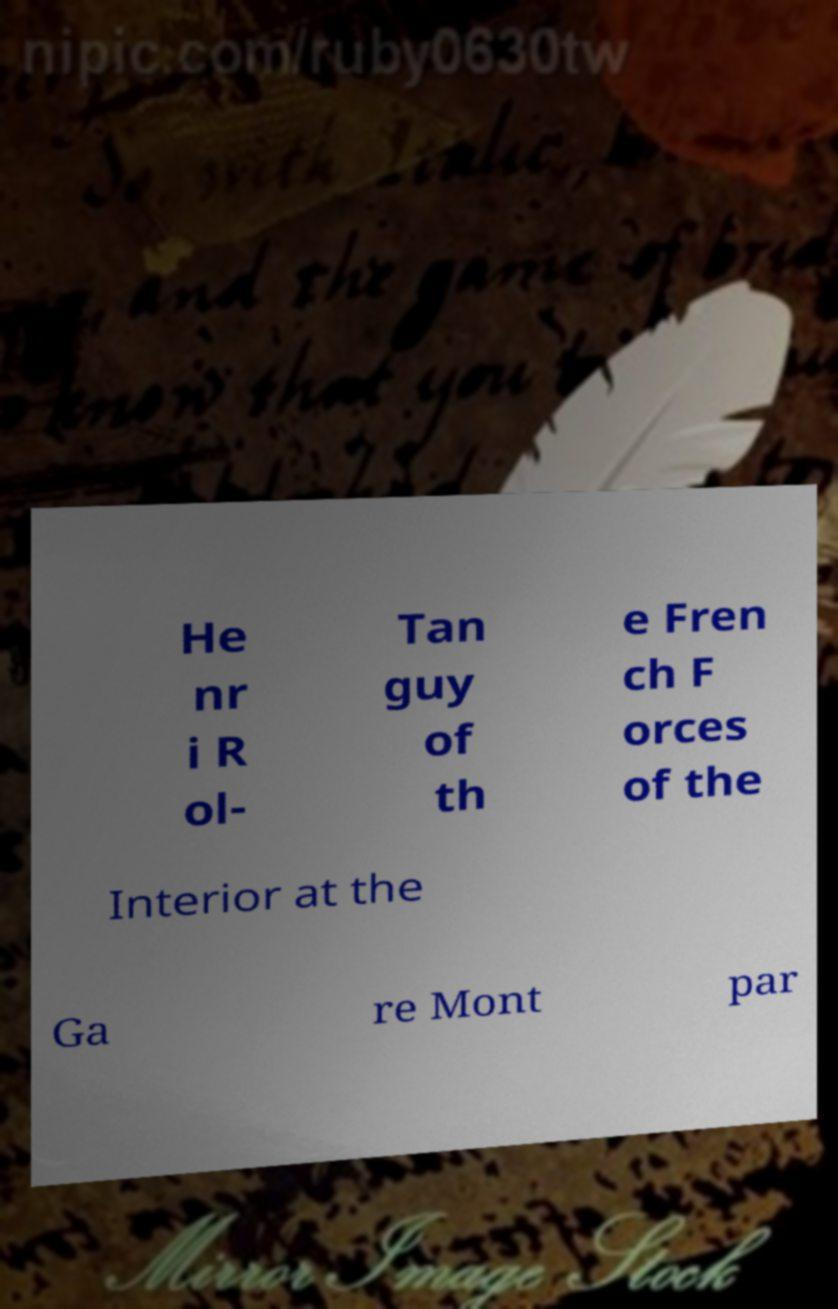There's text embedded in this image that I need extracted. Can you transcribe it verbatim? He nr i R ol- Tan guy of th e Fren ch F orces of the Interior at the Ga re Mont par 